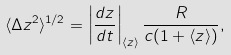<formula> <loc_0><loc_0><loc_500><loc_500>\langle \Delta z ^ { 2 } \rangle ^ { 1 / 2 } = \left | \frac { d z } { d t } \right | _ { \langle z \rangle } \frac { R } { c ( 1 + \langle z \rangle ) } ,</formula> 